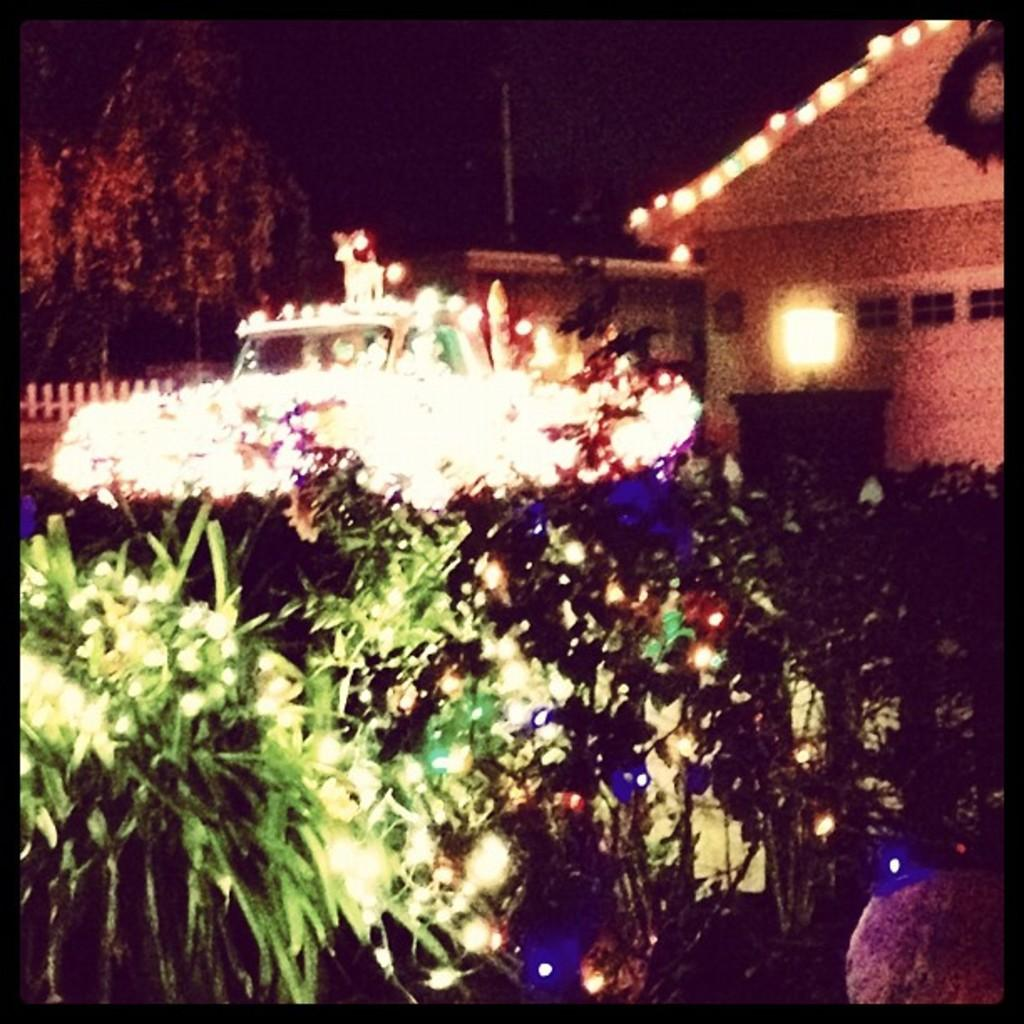At what time of day was the image captured? The image was captured during night time. What type of vegetation can be seen in the image? There are trees in the image. What type of structure is present in the image? There is a house in the image. What can be seen illuminating the scene in the image? There are lights visible in the image. What type of living organisms can be seen in the image besides trees? There are plants in the image. Can you see any goldfish swimming in the image? There are no goldfish present in the image. What type of chalk is being used to draw on the house in the image? There is no chalk or drawing on the house in the image. 